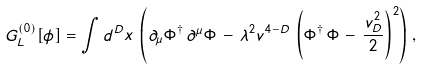<formula> <loc_0><loc_0><loc_500><loc_500>\ G ^ { ( 0 ) } _ { L } [ \phi ] = \int d ^ { D } x \, \left ( \partial _ { \mu } \Phi ^ { \dagger } \, \partial ^ { \mu } \Phi \, - \, \lambda ^ { 2 } v ^ { 4 - D } \, \left ( \Phi ^ { \dagger } \, \Phi \, - \, \frac { v ^ { 2 } _ { D } } { 2 } \right ) ^ { 2 } \right ) \, ,</formula> 